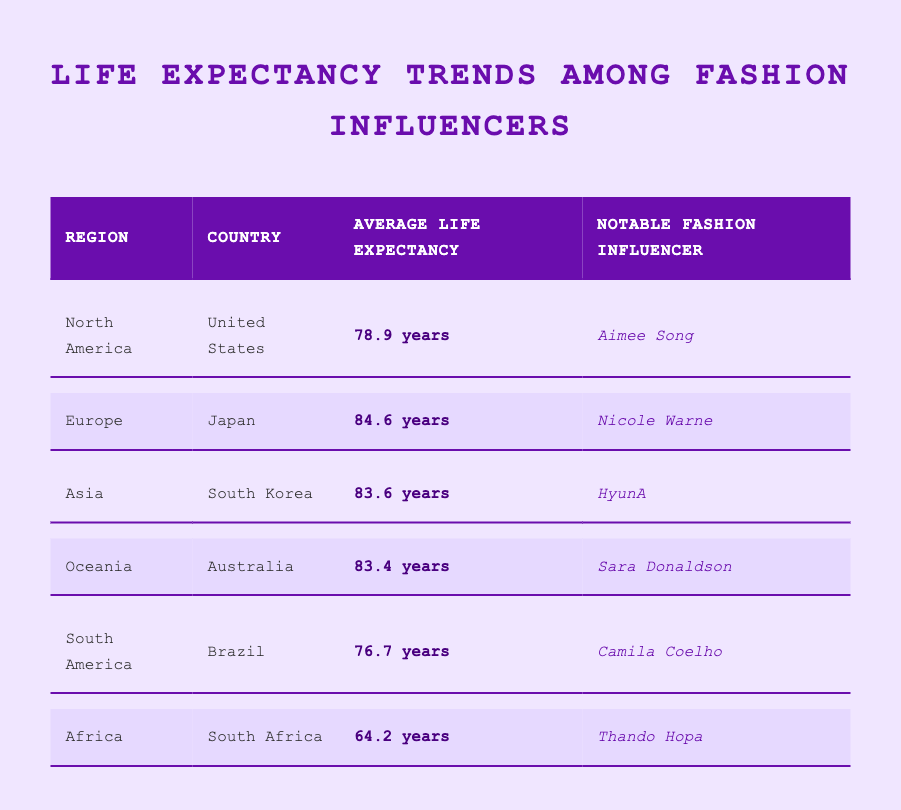What is the average life expectancy in Japan? The table lists the average life expectancy for Japan as 84.6 years.
Answer: 84.6 years Which region has the shortest average life expectancy? The shortest average life expectancy is listed for South Africa at 64.2 years, which is found in the Africa region.
Answer: South Africa What's the average life expectancy for fashion influencers in North America and South America combined? To find the average, we take the average life expectancy for North America (78.9 years) and South America (76.7 years). Adding these gives 155.6 years. Dividing by 2 yields an average of 77.8 years.
Answer: 77.8 years Is Aimee Song from Africa? Aimee Song is noted as the notable fashion influencer from the United States, which is in North America, not Africa.
Answer: No Which country has a higher average life expectancy, South Korea or Australia? From the table, South Korea has an average life expectancy of 83.6 years, while Australia has 83.4 years. Comparing these values shows that South Korea has a slightly higher average life expectancy.
Answer: South Korea What is the average life expectancy for Japan compared to South Africa? Japan's average life expectancy is 84.6 years, and South Africa's is 64.2 years. The difference is calculated by subtracting South Africa's life expectancy from Japan's: 84.6 - 64.2 = 20.4 years.
Answer: 20.4 years Is Nicole Warne the notable fashion influencer for Europe? Yes, the table identifies Nicole Warne as the notable fashion influencer for Japan, which is classified under the Europe region.
Answer: Yes Which regions have an average life expectancy above 80 years? The regions with average life expectancies above 80 years are Europe (84.6 years), Asia (83.6 years), and Oceania (83.4 years).
Answer: Europe, Asia, Oceania 